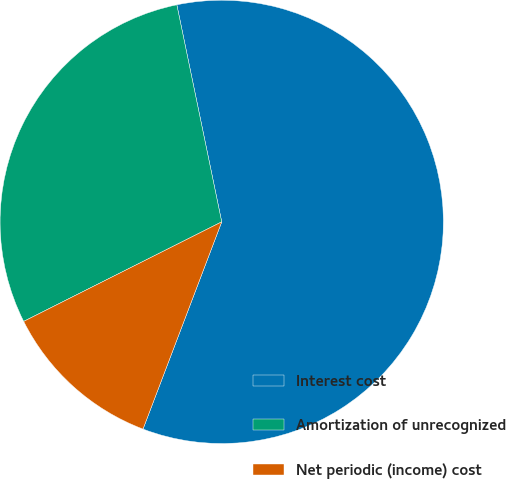Convert chart. <chart><loc_0><loc_0><loc_500><loc_500><pie_chart><fcel>Interest cost<fcel>Amortization of unrecognized<fcel>Net periodic (income) cost<nl><fcel>59.03%<fcel>29.17%<fcel>11.81%<nl></chart> 